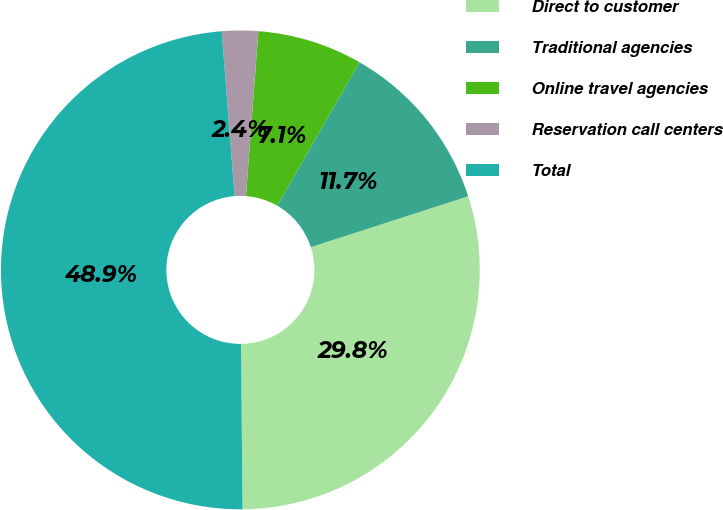<chart> <loc_0><loc_0><loc_500><loc_500><pie_chart><fcel>Direct to customer<fcel>Traditional agencies<fcel>Online travel agencies<fcel>Reservation call centers<fcel>Total<nl><fcel>29.83%<fcel>11.74%<fcel>7.09%<fcel>2.44%<fcel>48.9%<nl></chart> 